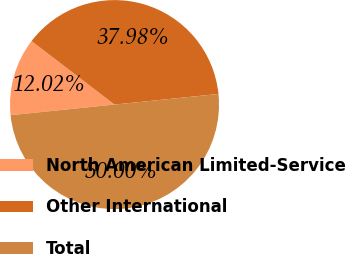<chart> <loc_0><loc_0><loc_500><loc_500><pie_chart><fcel>North American Limited-Service<fcel>Other International<fcel>Total<nl><fcel>12.02%<fcel>37.98%<fcel>50.0%<nl></chart> 